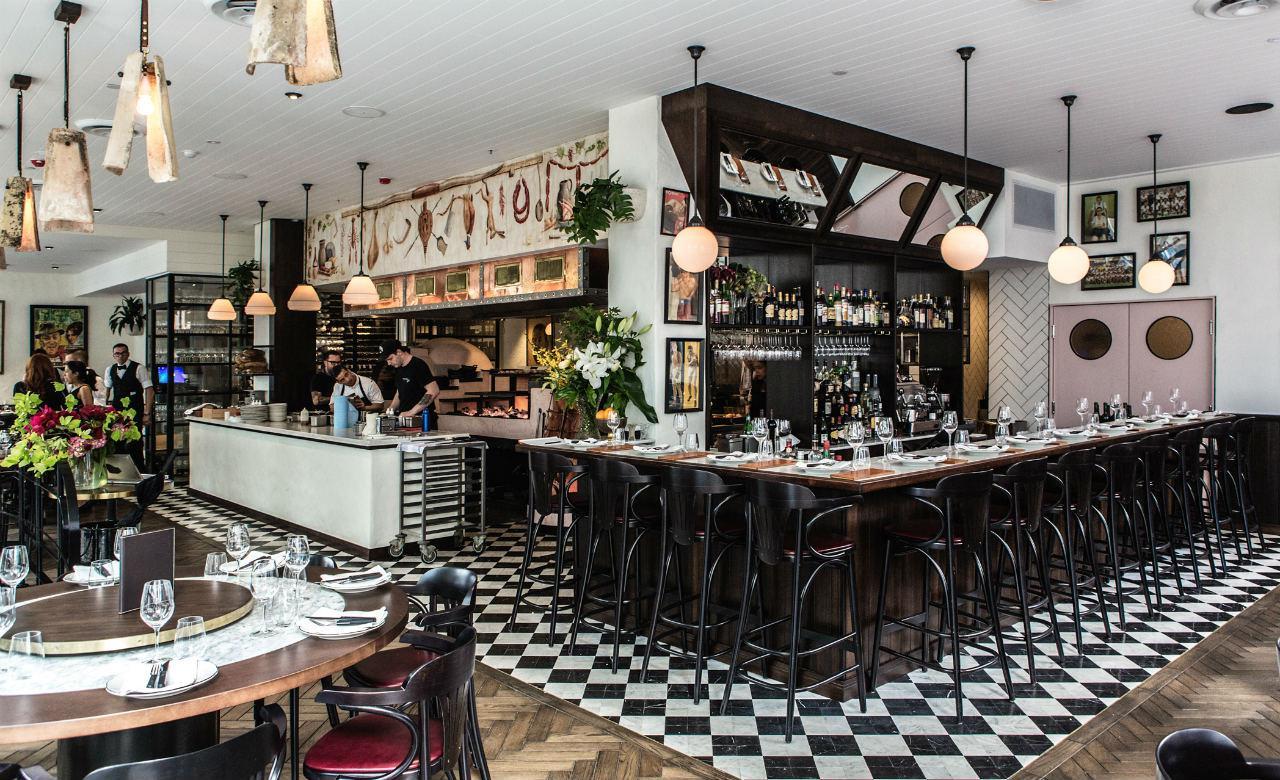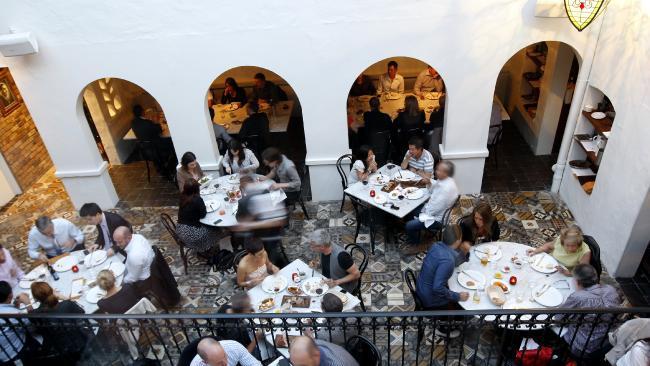The first image is the image on the left, the second image is the image on the right. For the images shown, is this caption "They are roasting pigs in one of the images." true? Answer yes or no. No. The first image is the image on the left, the second image is the image on the right. Assess this claim about the two images: "There are pigs surrounding a fire pit.". Correct or not? Answer yes or no. No. 